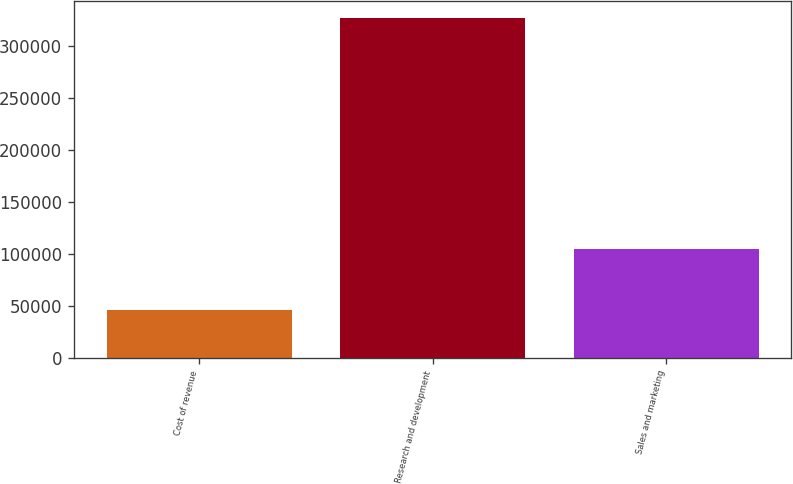Convert chart to OTSL. <chart><loc_0><loc_0><loc_500><loc_500><bar_chart><fcel>Cost of revenue<fcel>Research and development<fcel>Sales and marketing<nl><fcel>45927<fcel>326536<fcel>104084<nl></chart> 